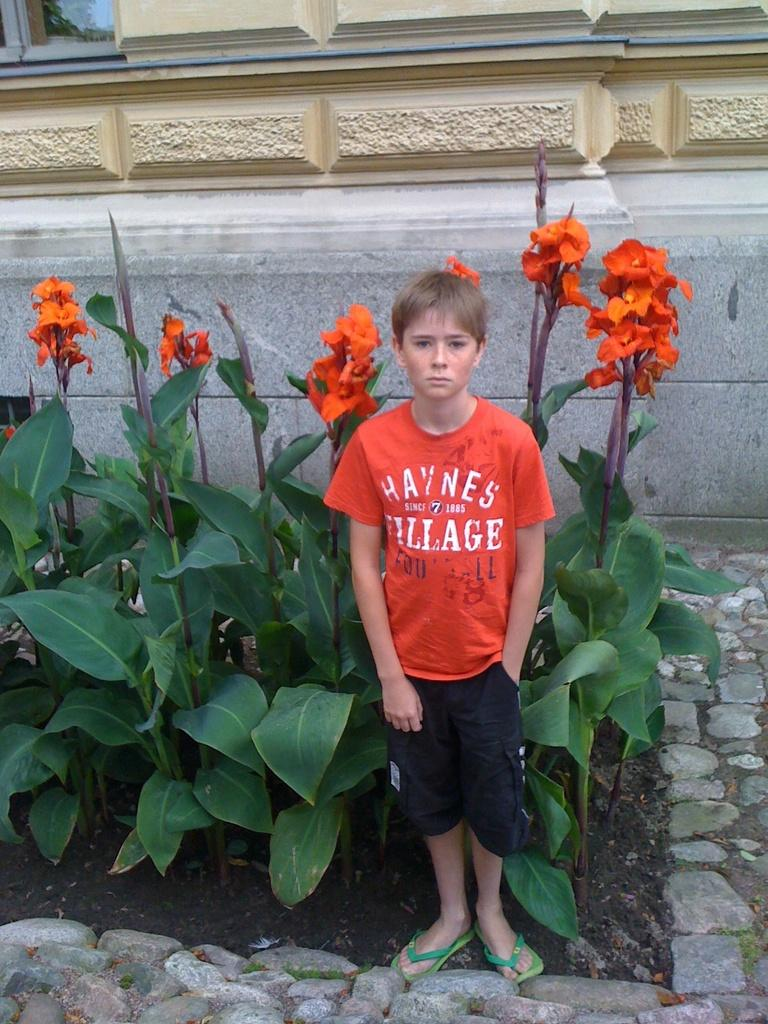What is the main subject of the image? There is a kid standing in the image. What can be seen in the background of the image? There are plants with leaves and flowers in the image, as well as a building. On what surface is the kid standing? The kid is standing on a rock surface. Where is the shelf located in the image? There is no shelf present in the image. What is the kid saying during the meeting in the image? There is no meeting or any indication of speech in the image. 